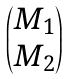<formula> <loc_0><loc_0><loc_500><loc_500>\begin{pmatrix} M _ { 1 } \\ M _ { 2 } \end{pmatrix}</formula> 